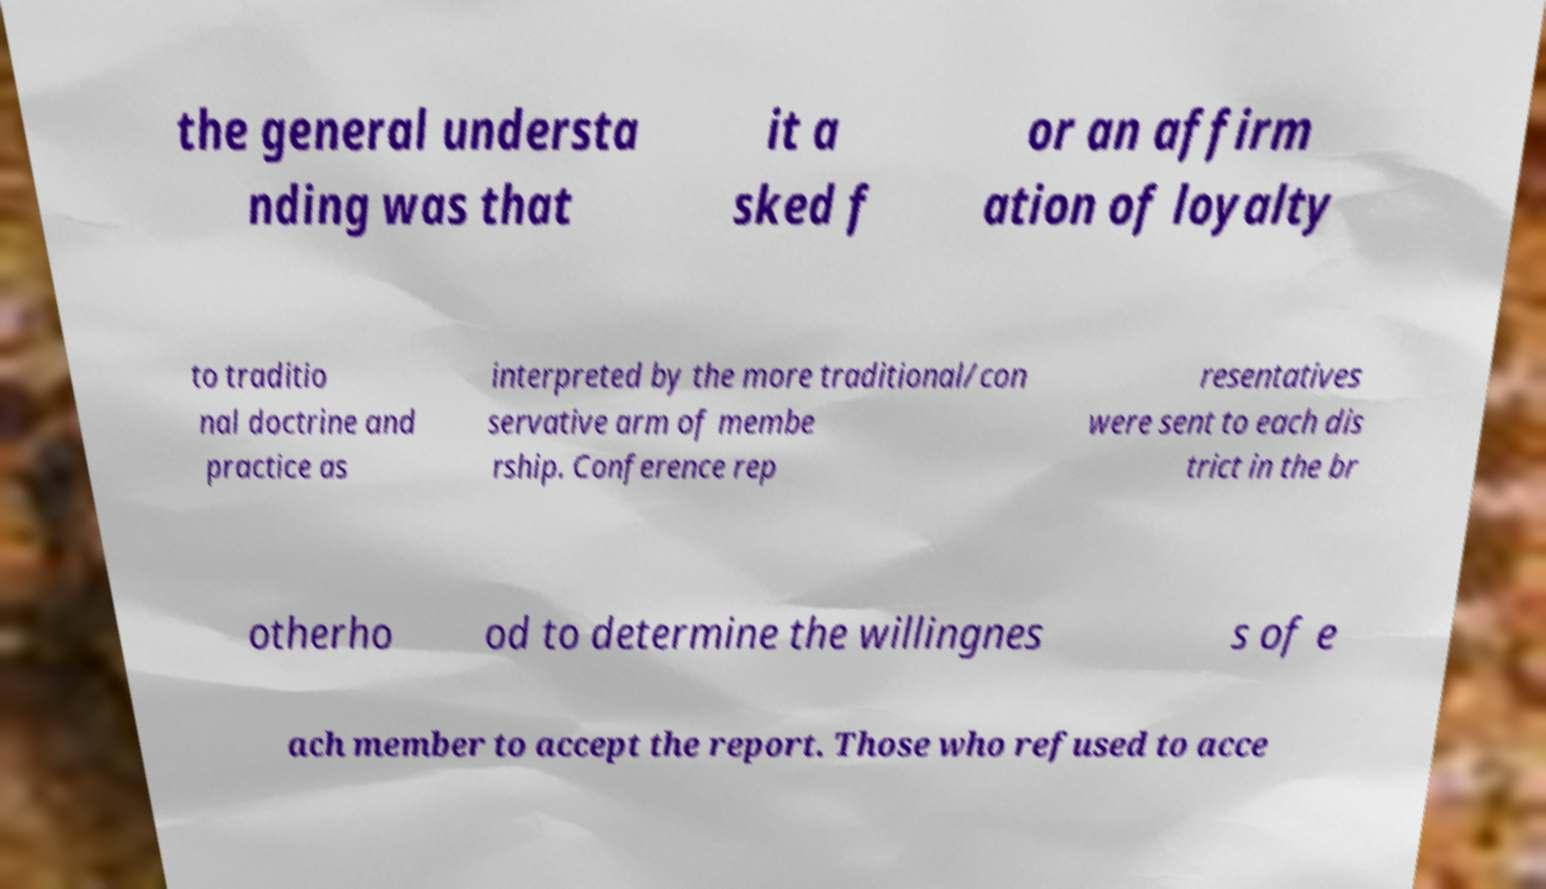Please read and relay the text visible in this image. What does it say? the general understa nding was that it a sked f or an affirm ation of loyalty to traditio nal doctrine and practice as interpreted by the more traditional/con servative arm of membe rship. Conference rep resentatives were sent to each dis trict in the br otherho od to determine the willingnes s of e ach member to accept the report. Those who refused to acce 